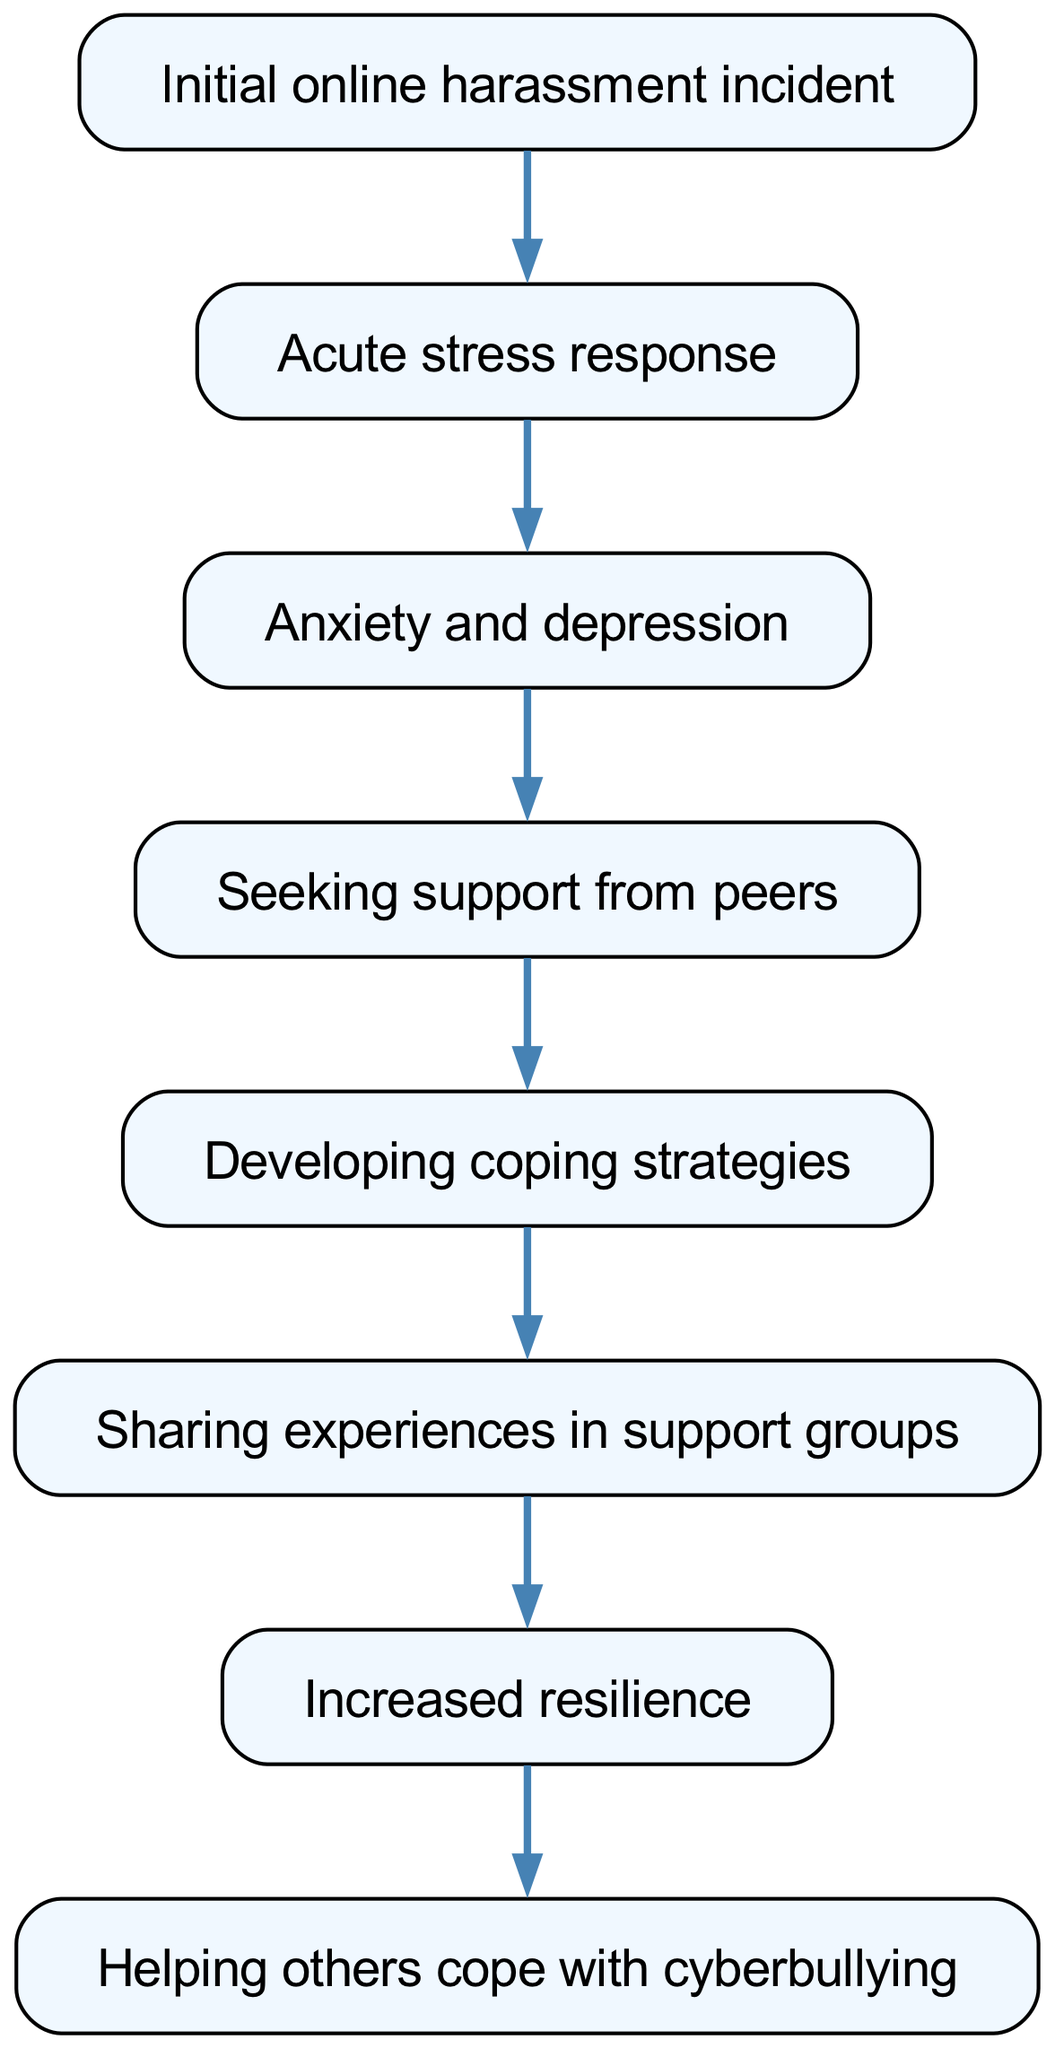What is the first step in the psychological impacts of cyberbullying? The diagram starts with an initial online harassment incident, which is depicted as the first node in the chain.
Answer: Initial online harassment incident How many connections are there in the diagram? To find this, we count the "connections" listed in the data. There are 7 connections linking the elements.
Answer: 7 What follows the acute stress response in the diagram? According to the flow of the diagram, the acute stress response leads to anxiety and depression, which is the next node connected to it.
Answer: Anxiety and depression Which element represents support-seeking behavior? The diagram indicates that after experiencing anxiety and depression, individuals seek support from peers, which is shown in the corresponding node.
Answer: Seeking support from peers What is the relationship between sharing experiences and resilience? The diagram shows that sharing experiences in support groups leads to increased resilience, indicating a directional relationship between these two nodes.
Answer: Increased resilience Which element comes after developing coping strategies? Following the development of coping strategies, the flow of the diagram indicates that individuals start sharing their experiences in support groups.
Answer: Sharing experiences in support groups How does one help others according to the flow? The diagram shows that after increasing resilience, individuals can help others cope with cyberbullying, illustrating a direct flow from increased resilience to this action.
Answer: Helping others cope with cyberbullying 